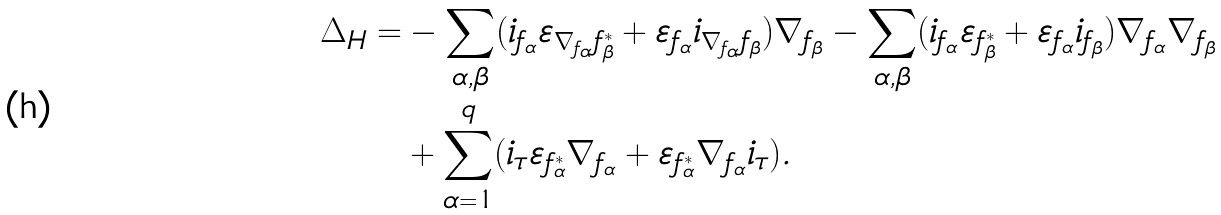Convert formula to latex. <formula><loc_0><loc_0><loc_500><loc_500>\Delta _ { H } = & - \sum _ { \alpha , \beta } ( i _ { f _ { \alpha } } \varepsilon _ { \nabla _ { f _ { \alpha } } f ^ { * } _ { \beta } } + \varepsilon _ { f _ { \alpha } } i _ { \nabla _ { f _ { \alpha } } f _ { \beta } } ) \nabla _ { f _ { \beta } } - \sum _ { \alpha , \beta } ( i _ { f _ { \alpha } } \varepsilon _ { f ^ { * } _ { \beta } } + \varepsilon _ { f _ { \alpha } } i _ { f _ { \beta } } ) \nabla _ { f _ { \alpha } } \nabla _ { f _ { \beta } } \\ & + \sum _ { \alpha = 1 } ^ { q } ( i _ { \tau } \varepsilon _ { f ^ { * } _ { \alpha } } \nabla _ { f _ { \alpha } } + \varepsilon _ { f ^ { * } _ { \alpha } } \nabla _ { f _ { \alpha } } i _ { \tau } ) .</formula> 